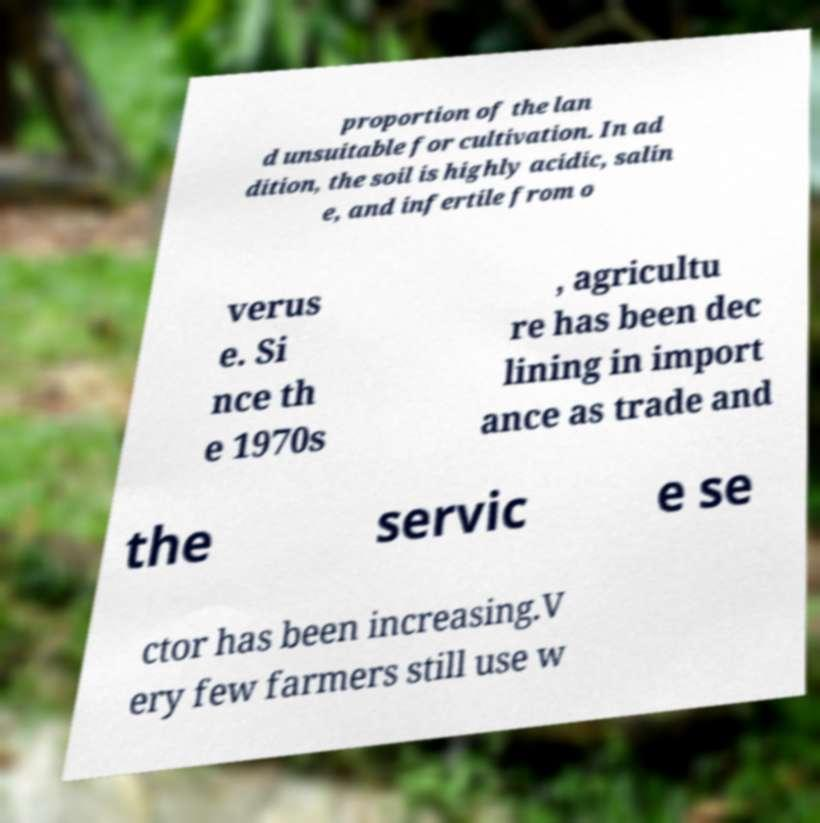I need the written content from this picture converted into text. Can you do that? proportion of the lan d unsuitable for cultivation. In ad dition, the soil is highly acidic, salin e, and infertile from o verus e. Si nce th e 1970s , agricultu re has been dec lining in import ance as trade and the servic e se ctor has been increasing.V ery few farmers still use w 